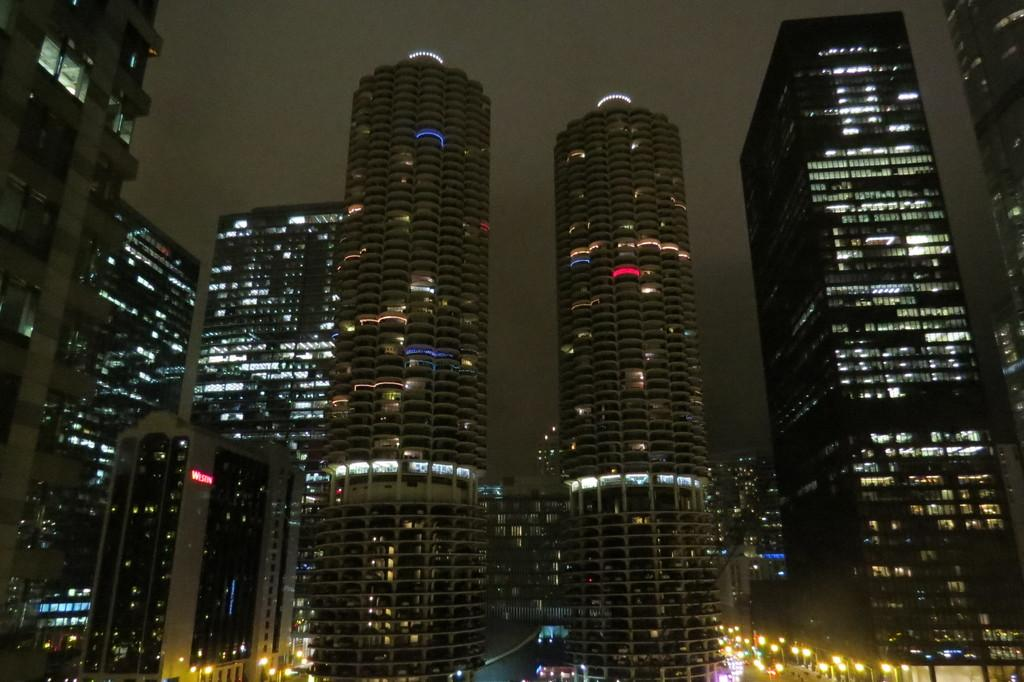What type of structures can be seen in the image? There are buildings in the image. What else can be observed in the image besides the buildings? There are lights visible in the image. Is there any quicksand present in the image? There is no quicksand present in the image. What type of metal is used to make the lights in the image? The provided facts do not mention the type of metal used for the lights, so we cannot determine if they are made of brass or any other material. 